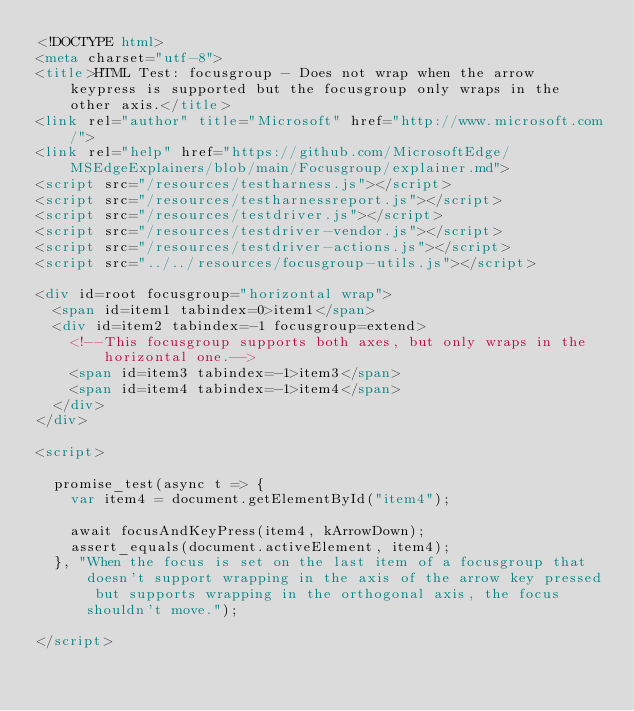<code> <loc_0><loc_0><loc_500><loc_500><_HTML_><!DOCTYPE html>
<meta charset="utf-8">
<title>HTML Test: focusgroup - Does not wrap when the arrow keypress is supported but the focusgroup only wraps in the other axis.</title>
<link rel="author" title="Microsoft" href="http://www.microsoft.com/">
<link rel="help" href="https://github.com/MicrosoftEdge/MSEdgeExplainers/blob/main/Focusgroup/explainer.md">
<script src="/resources/testharness.js"></script>
<script src="/resources/testharnessreport.js"></script>
<script src="/resources/testdriver.js"></script>
<script src="/resources/testdriver-vendor.js"></script>
<script src="/resources/testdriver-actions.js"></script>
<script src="../../resources/focusgroup-utils.js"></script>

<div id=root focusgroup="horizontal wrap">
  <span id=item1 tabindex=0>item1</span>
  <div id=item2 tabindex=-1 focusgroup=extend>
    <!--This focusgroup supports both axes, but only wraps in the horizontal one.-->
    <span id=item3 tabindex=-1>item3</span>
    <span id=item4 tabindex=-1>item4</span>
  </div>
</div>

<script>

  promise_test(async t => {
    var item4 = document.getElementById("item4");

    await focusAndKeyPress(item4, kArrowDown);
    assert_equals(document.activeElement, item4);
  }, "When the focus is set on the last item of a focusgroup that doesn't support wrapping in the axis of the arrow key pressed but supports wrapping in the orthogonal axis, the focus shouldn't move.");

</script></code> 